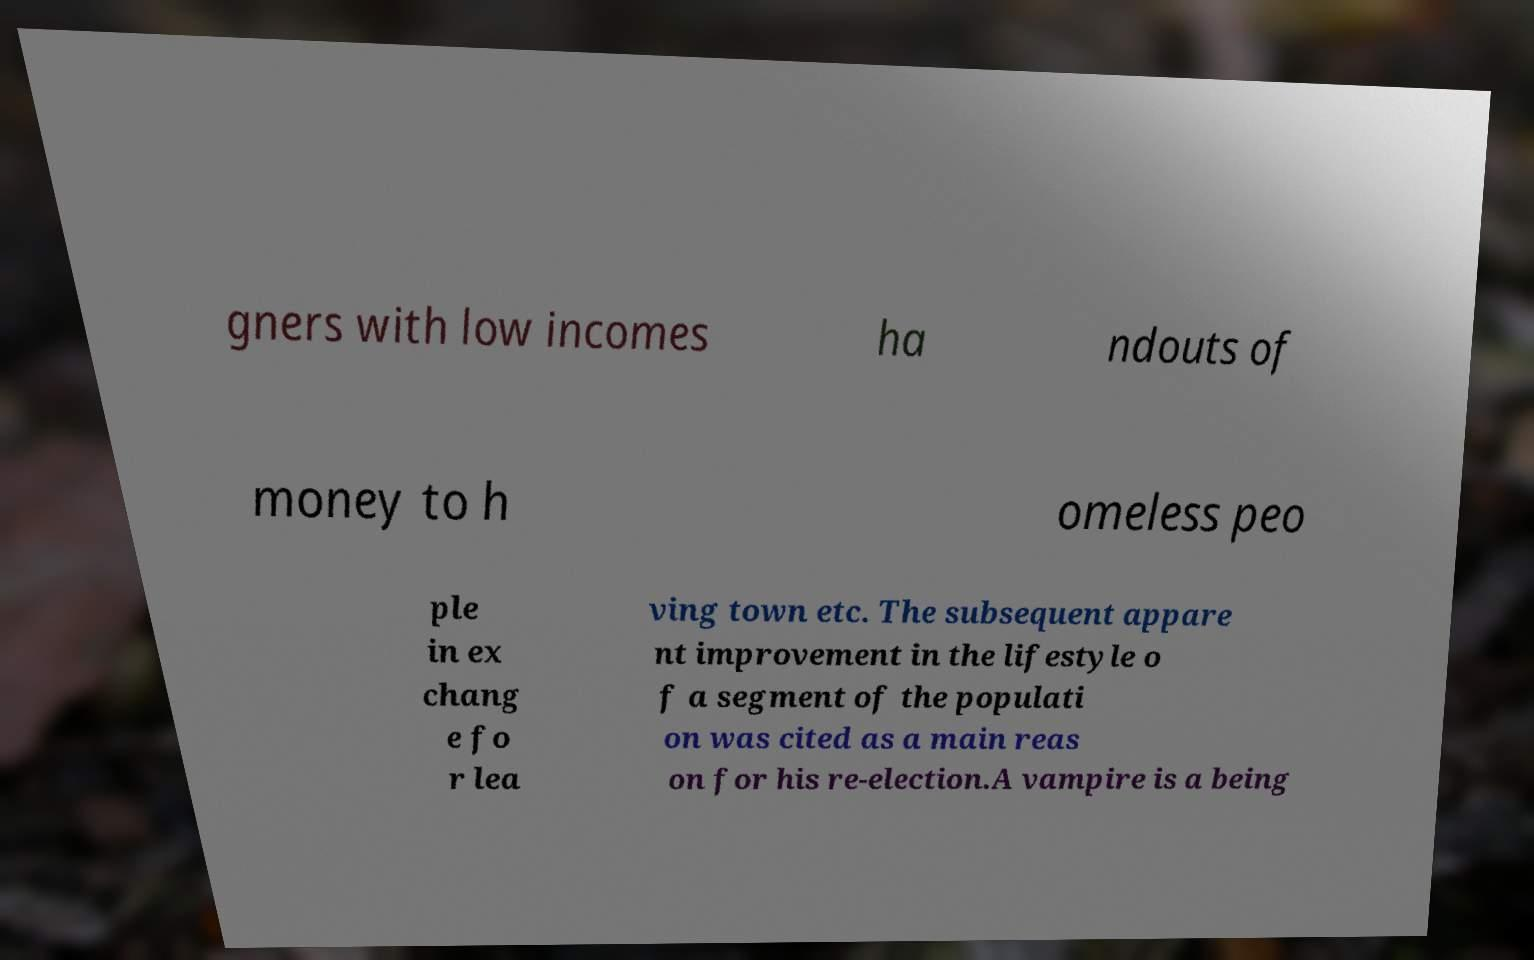There's text embedded in this image that I need extracted. Can you transcribe it verbatim? gners with low incomes ha ndouts of money to h omeless peo ple in ex chang e fo r lea ving town etc. The subsequent appare nt improvement in the lifestyle o f a segment of the populati on was cited as a main reas on for his re-election.A vampire is a being 